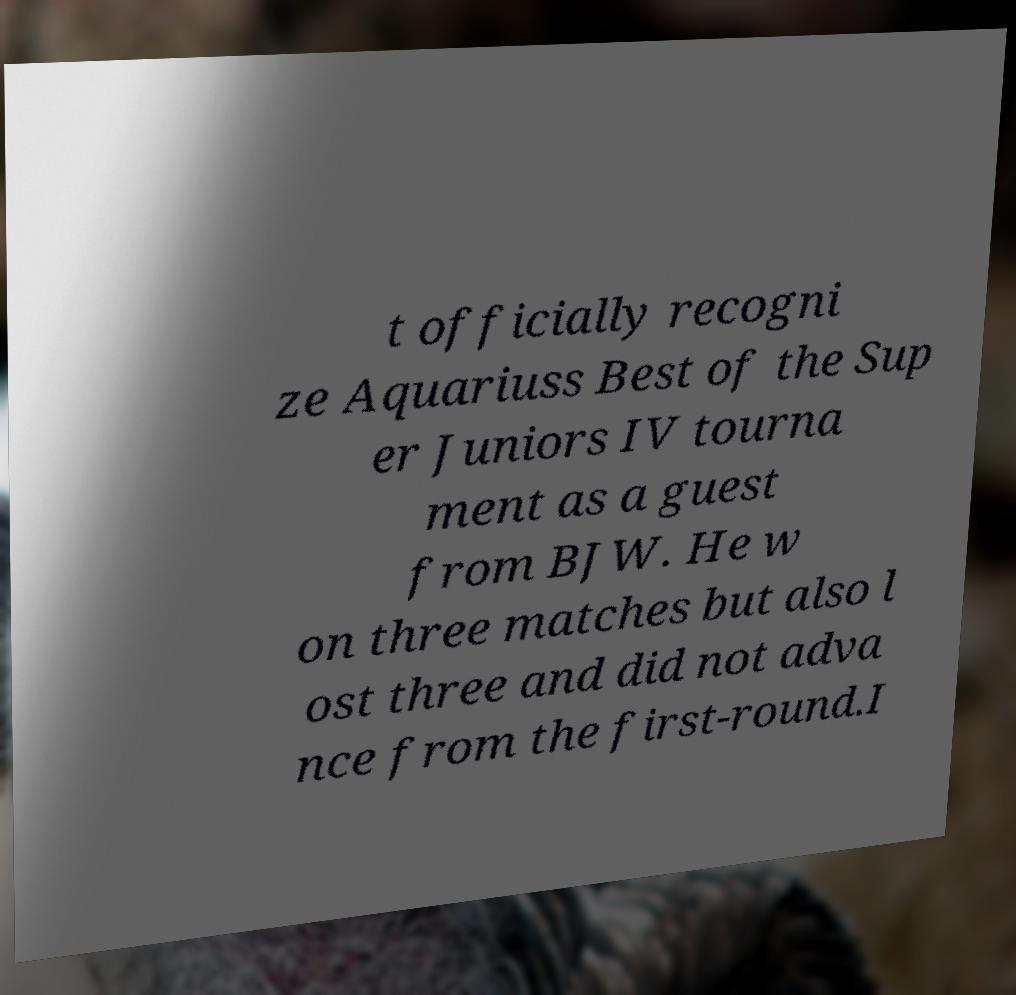For documentation purposes, I need the text within this image transcribed. Could you provide that? t officially recogni ze Aquariuss Best of the Sup er Juniors IV tourna ment as a guest from BJW. He w on three matches but also l ost three and did not adva nce from the first-round.I 